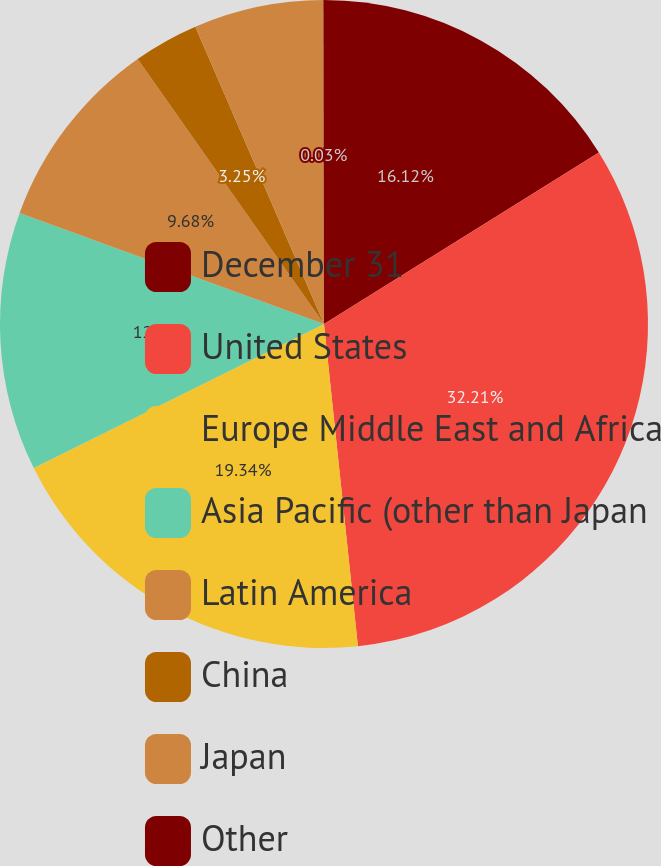Convert chart. <chart><loc_0><loc_0><loc_500><loc_500><pie_chart><fcel>December 31<fcel>United States<fcel>Europe Middle East and Africa<fcel>Asia Pacific (other than Japan<fcel>Latin America<fcel>China<fcel>Japan<fcel>Other<nl><fcel>16.12%<fcel>32.21%<fcel>19.34%<fcel>12.9%<fcel>9.68%<fcel>3.25%<fcel>6.47%<fcel>0.03%<nl></chart> 